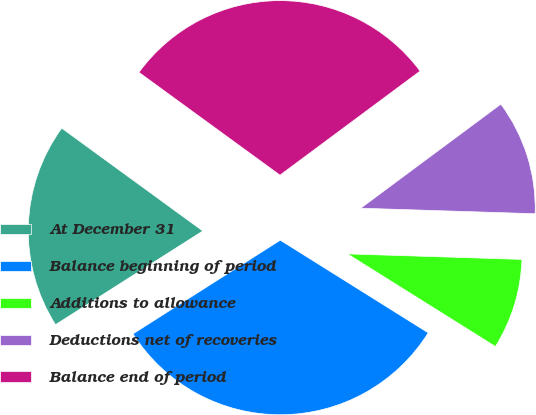<chart> <loc_0><loc_0><loc_500><loc_500><pie_chart><fcel>At December 31<fcel>Balance beginning of period<fcel>Additions to allowance<fcel>Deductions net of recoveries<fcel>Balance end of period<nl><fcel>19.04%<fcel>32.08%<fcel>8.4%<fcel>10.67%<fcel>29.81%<nl></chart> 